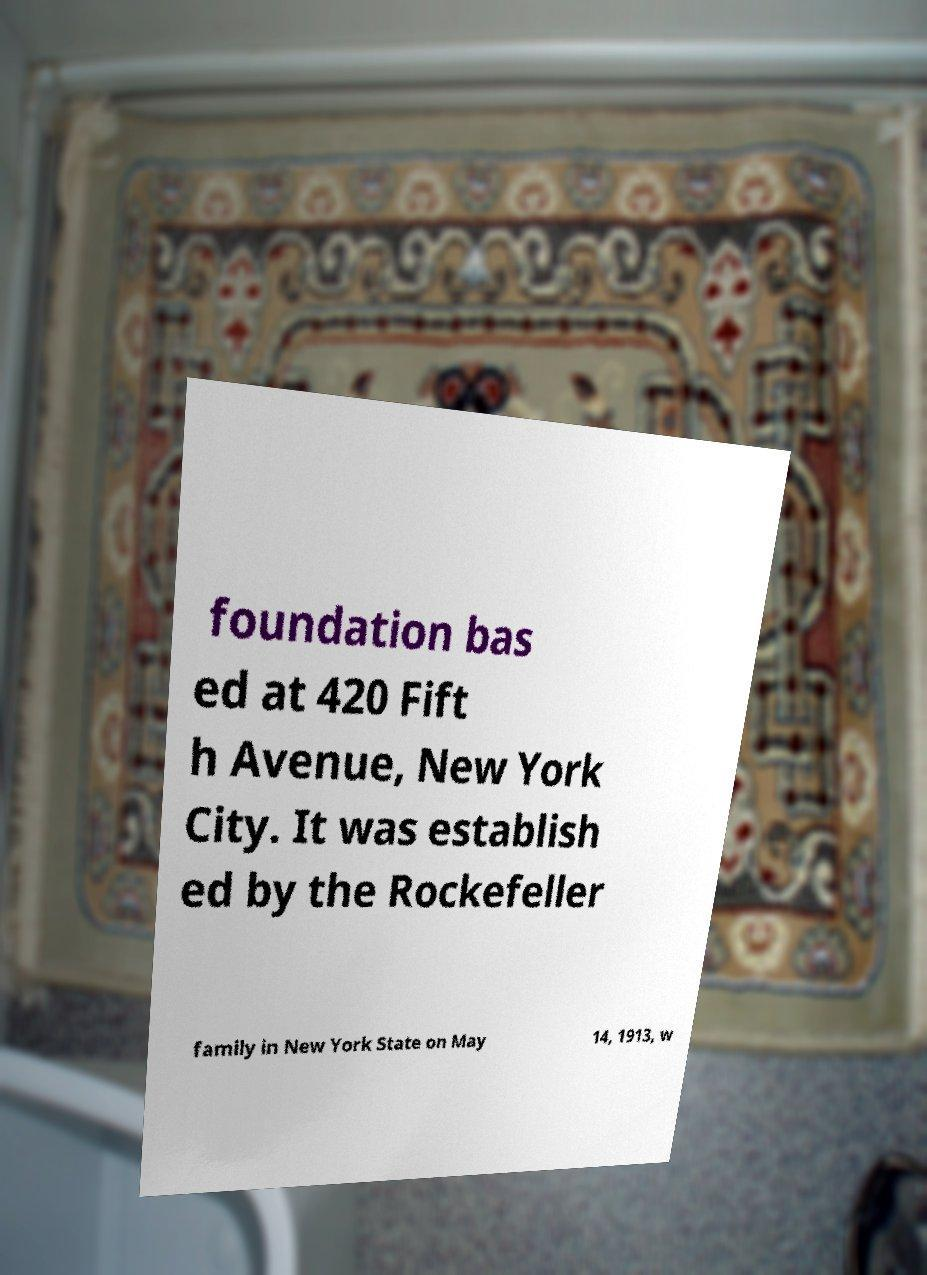There's text embedded in this image that I need extracted. Can you transcribe it verbatim? foundation bas ed at 420 Fift h Avenue, New York City. It was establish ed by the Rockefeller family in New York State on May 14, 1913, w 